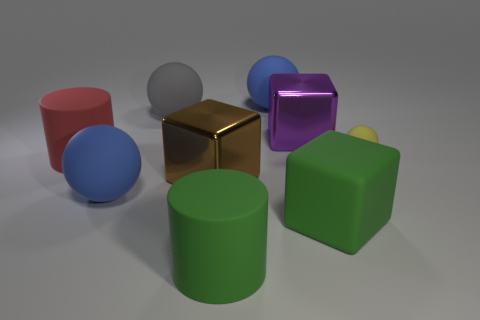Subtract all green rubber blocks. How many blocks are left? 2 Add 1 big green objects. How many objects exist? 10 Subtract all gray balls. How many balls are left? 3 Subtract all red matte things. Subtract all big yellow shiny balls. How many objects are left? 8 Add 2 large gray matte balls. How many large gray matte balls are left? 3 Add 3 large rubber cubes. How many large rubber cubes exist? 4 Subtract 0 brown balls. How many objects are left? 9 Subtract all blocks. How many objects are left? 6 Subtract 2 spheres. How many spheres are left? 2 Subtract all red blocks. Subtract all green spheres. How many blocks are left? 3 